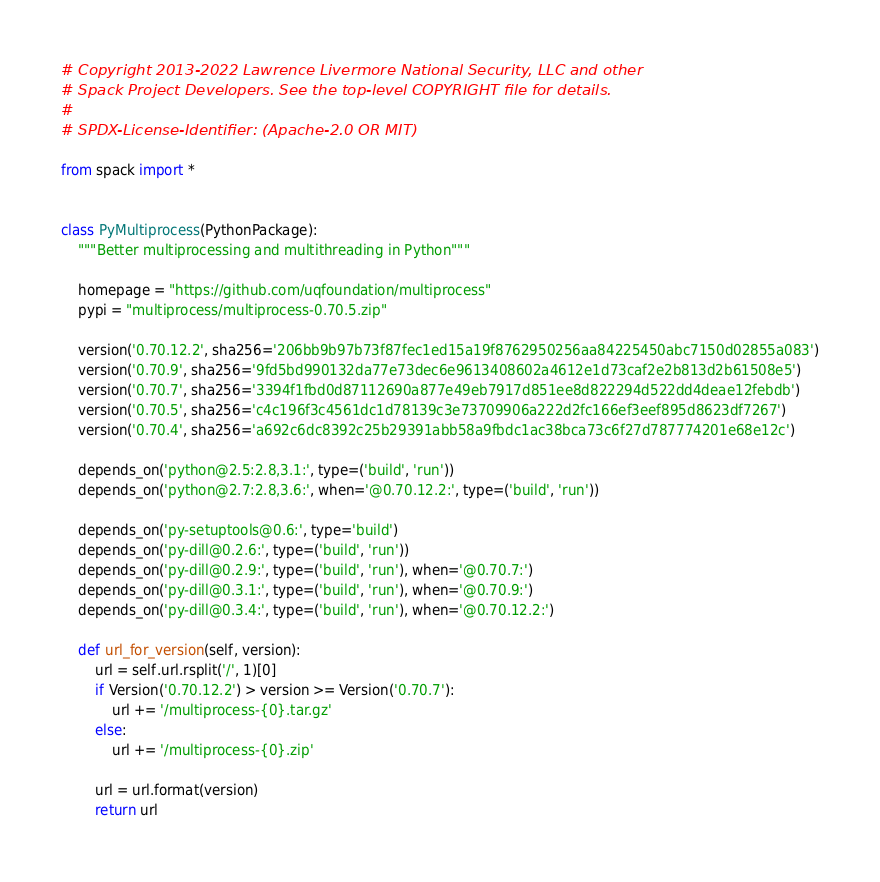<code> <loc_0><loc_0><loc_500><loc_500><_Python_># Copyright 2013-2022 Lawrence Livermore National Security, LLC and other
# Spack Project Developers. See the top-level COPYRIGHT file for details.
#
# SPDX-License-Identifier: (Apache-2.0 OR MIT)

from spack import *


class PyMultiprocess(PythonPackage):
    """Better multiprocessing and multithreading in Python"""

    homepage = "https://github.com/uqfoundation/multiprocess"
    pypi = "multiprocess/multiprocess-0.70.5.zip"

    version('0.70.12.2', sha256='206bb9b97b73f87fec1ed15a19f8762950256aa84225450abc7150d02855a083')
    version('0.70.9', sha256='9fd5bd990132da77e73dec6e9613408602a4612e1d73caf2e2b813d2b61508e5')
    version('0.70.7', sha256='3394f1fbd0d87112690a877e49eb7917d851ee8d822294d522dd4deae12febdb')
    version('0.70.5', sha256='c4c196f3c4561dc1d78139c3e73709906a222d2fc166ef3eef895d8623df7267')
    version('0.70.4', sha256='a692c6dc8392c25b29391abb58a9fbdc1ac38bca73c6f27d787774201e68e12c')

    depends_on('python@2.5:2.8,3.1:', type=('build', 'run'))
    depends_on('python@2.7:2.8,3.6:', when='@0.70.12.2:', type=('build', 'run'))

    depends_on('py-setuptools@0.6:', type='build')
    depends_on('py-dill@0.2.6:', type=('build', 'run'))
    depends_on('py-dill@0.2.9:', type=('build', 'run'), when='@0.70.7:')
    depends_on('py-dill@0.3.1:', type=('build', 'run'), when='@0.70.9:')
    depends_on('py-dill@0.3.4:', type=('build', 'run'), when='@0.70.12.2:')

    def url_for_version(self, version):
        url = self.url.rsplit('/', 1)[0]
        if Version('0.70.12.2') > version >= Version('0.70.7'):
            url += '/multiprocess-{0}.tar.gz'
        else:
            url += '/multiprocess-{0}.zip'

        url = url.format(version)
        return url
</code> 